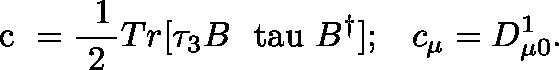Convert formula to latex. <formula><loc_0><loc_0><loc_500><loc_500>\boldmath c = \frac { 1 } { 2 } T r [ \tau _ { 3 } B \boldmath \ t a u B ^ { \dagger } ] ; \, c _ { \mu } = D _ { \mu 0 } ^ { 1 } .</formula> 